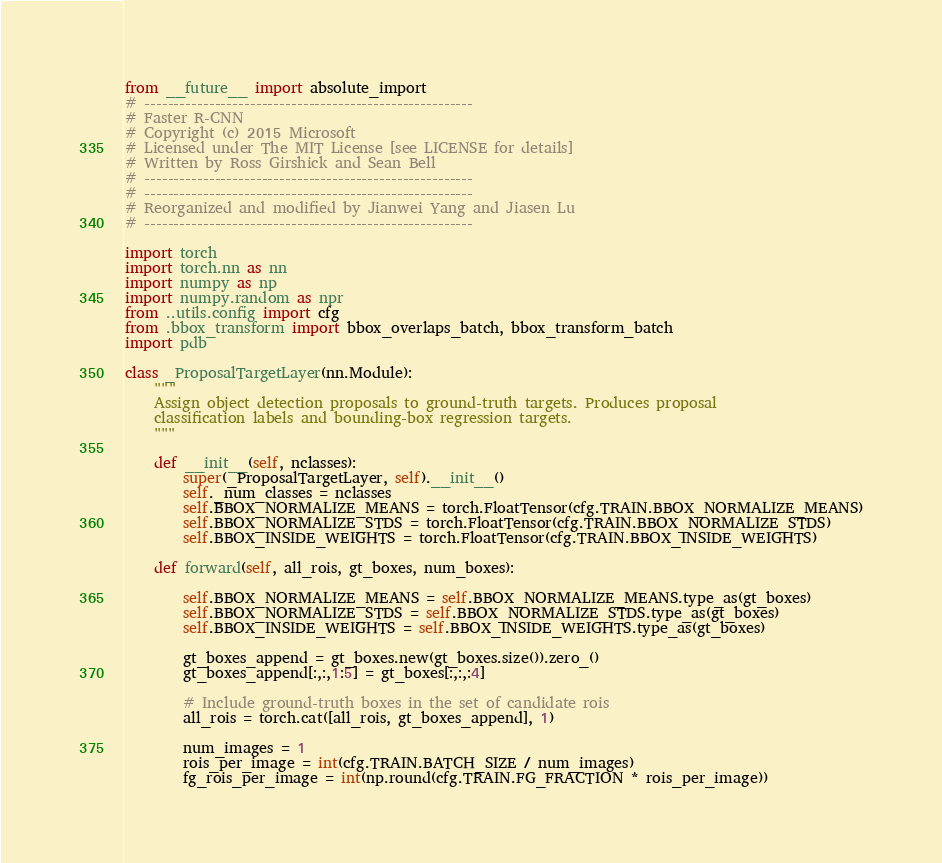Convert code to text. <code><loc_0><loc_0><loc_500><loc_500><_Python_>from __future__ import absolute_import
# --------------------------------------------------------
# Faster R-CNN
# Copyright (c) 2015 Microsoft
# Licensed under The MIT License [see LICENSE for details]
# Written by Ross Girshick and Sean Bell
# --------------------------------------------------------
# --------------------------------------------------------
# Reorganized and modified by Jianwei Yang and Jiasen Lu
# --------------------------------------------------------

import torch
import torch.nn as nn
import numpy as np
import numpy.random as npr
from ..utils.config import cfg
from .bbox_transform import bbox_overlaps_batch, bbox_transform_batch
import pdb

class _ProposalTargetLayer(nn.Module):
    """
    Assign object detection proposals to ground-truth targets. Produces proposal
    classification labels and bounding-box regression targets.
    """

    def __init__(self, nclasses):
        super(_ProposalTargetLayer, self).__init__()
        self._num_classes = nclasses
        self.BBOX_NORMALIZE_MEANS = torch.FloatTensor(cfg.TRAIN.BBOX_NORMALIZE_MEANS)
        self.BBOX_NORMALIZE_STDS = torch.FloatTensor(cfg.TRAIN.BBOX_NORMALIZE_STDS)
        self.BBOX_INSIDE_WEIGHTS = torch.FloatTensor(cfg.TRAIN.BBOX_INSIDE_WEIGHTS)

    def forward(self, all_rois, gt_boxes, num_boxes):

        self.BBOX_NORMALIZE_MEANS = self.BBOX_NORMALIZE_MEANS.type_as(gt_boxes)
        self.BBOX_NORMALIZE_STDS = self.BBOX_NORMALIZE_STDS.type_as(gt_boxes)
        self.BBOX_INSIDE_WEIGHTS = self.BBOX_INSIDE_WEIGHTS.type_as(gt_boxes)

        gt_boxes_append = gt_boxes.new(gt_boxes.size()).zero_()
        gt_boxes_append[:,:,1:5] = gt_boxes[:,:,:4]

        # Include ground-truth boxes in the set of candidate rois
        all_rois = torch.cat([all_rois, gt_boxes_append], 1)

        num_images = 1
        rois_per_image = int(cfg.TRAIN.BATCH_SIZE / num_images)
        fg_rois_per_image = int(np.round(cfg.TRAIN.FG_FRACTION * rois_per_image))</code> 